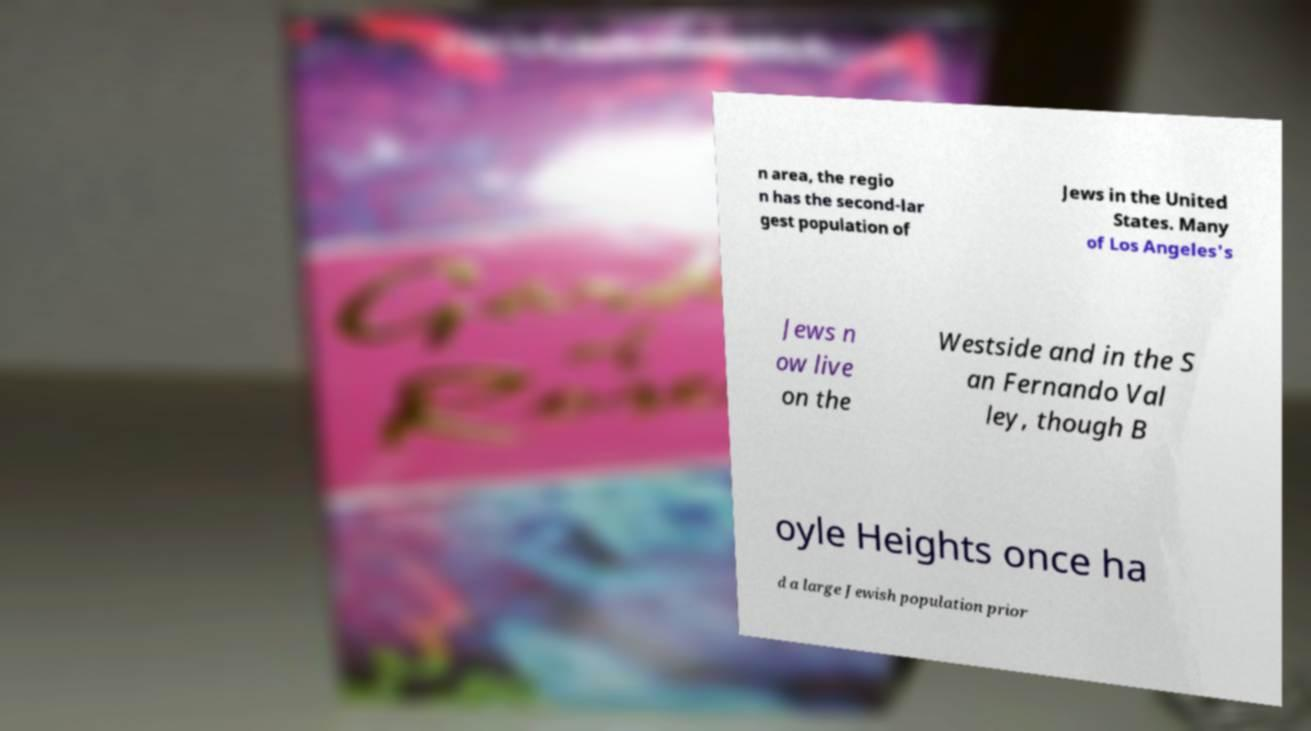Could you assist in decoding the text presented in this image and type it out clearly? n area, the regio n has the second-lar gest population of Jews in the United States. Many of Los Angeles's Jews n ow live on the Westside and in the S an Fernando Val ley, though B oyle Heights once ha d a large Jewish population prior 